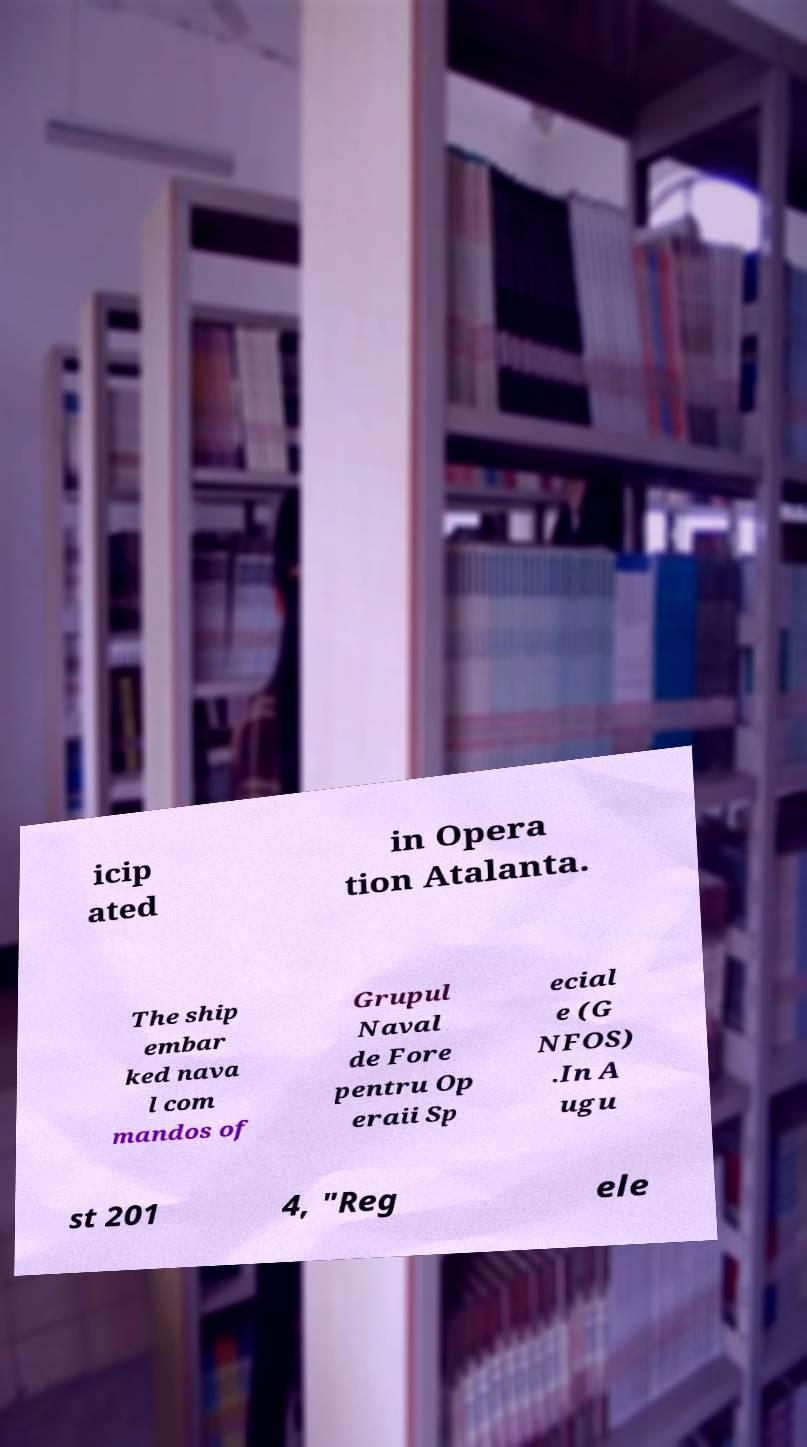What messages or text are displayed in this image? I need them in a readable, typed format. icip ated in Opera tion Atalanta. The ship embar ked nava l com mandos of Grupul Naval de Fore pentru Op eraii Sp ecial e (G NFOS) .In A ugu st 201 4, "Reg ele 